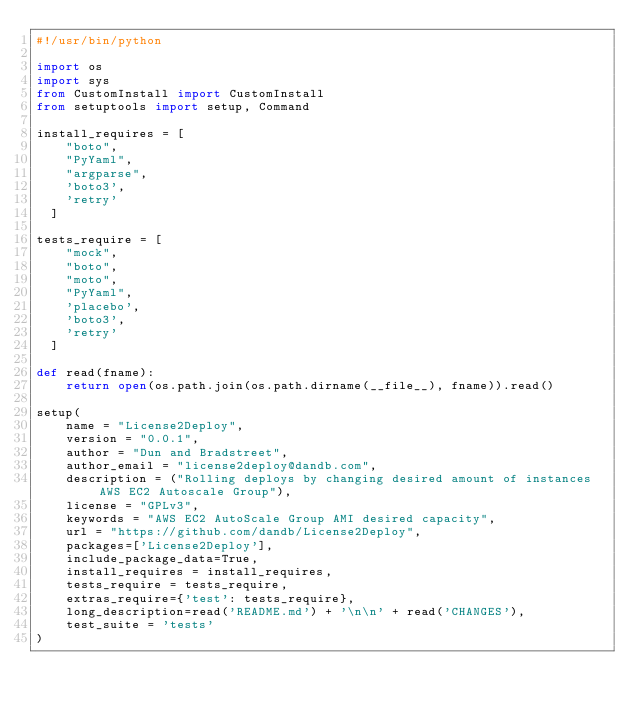Convert code to text. <code><loc_0><loc_0><loc_500><loc_500><_Python_>#!/usr/bin/python

import os
import sys
from CustomInstall import CustomInstall
from setuptools import setup, Command

install_requires = [
    "boto",
    "PyYaml",
    "argparse",
    'boto3',
    'retry'
  ]

tests_require = [
    "mock",
    "boto",
    "moto",
    "PyYaml",
    'placebo',
    'boto3',
    'retry'
  ]

def read(fname):
    return open(os.path.join(os.path.dirname(__file__), fname)).read()

setup(
    name = "License2Deploy",
    version = "0.0.1",
    author = "Dun and Bradstreet",
    author_email = "license2deploy@dandb.com",
    description = ("Rolling deploys by changing desired amount of instances AWS EC2 Autoscale Group"),
    license = "GPLv3",
    keywords = "AWS EC2 AutoScale Group AMI desired capacity",
    url = "https://github.com/dandb/License2Deploy",
    packages=['License2Deploy'],
    include_package_data=True,
    install_requires = install_requires,
    tests_require = tests_require,
    extras_require={'test': tests_require},
    long_description=read('README.md') + '\n\n' + read('CHANGES'),
    test_suite = 'tests'
)
</code> 